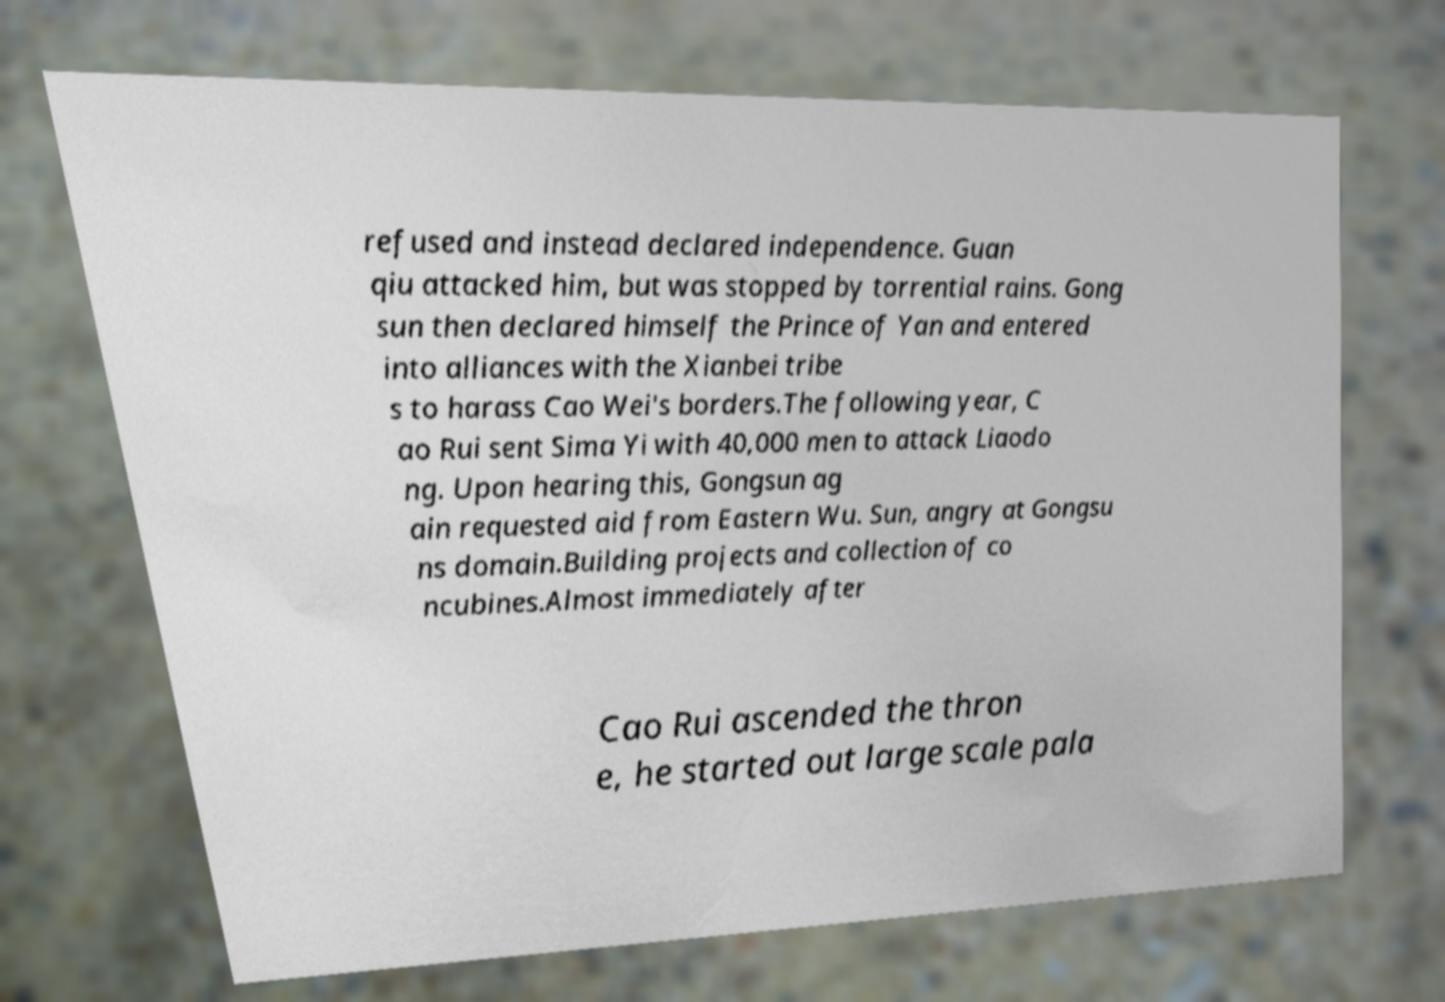Could you extract and type out the text from this image? refused and instead declared independence. Guan qiu attacked him, but was stopped by torrential rains. Gong sun then declared himself the Prince of Yan and entered into alliances with the Xianbei tribe s to harass Cao Wei's borders.The following year, C ao Rui sent Sima Yi with 40,000 men to attack Liaodo ng. Upon hearing this, Gongsun ag ain requested aid from Eastern Wu. Sun, angry at Gongsu ns domain.Building projects and collection of co ncubines.Almost immediately after Cao Rui ascended the thron e, he started out large scale pala 